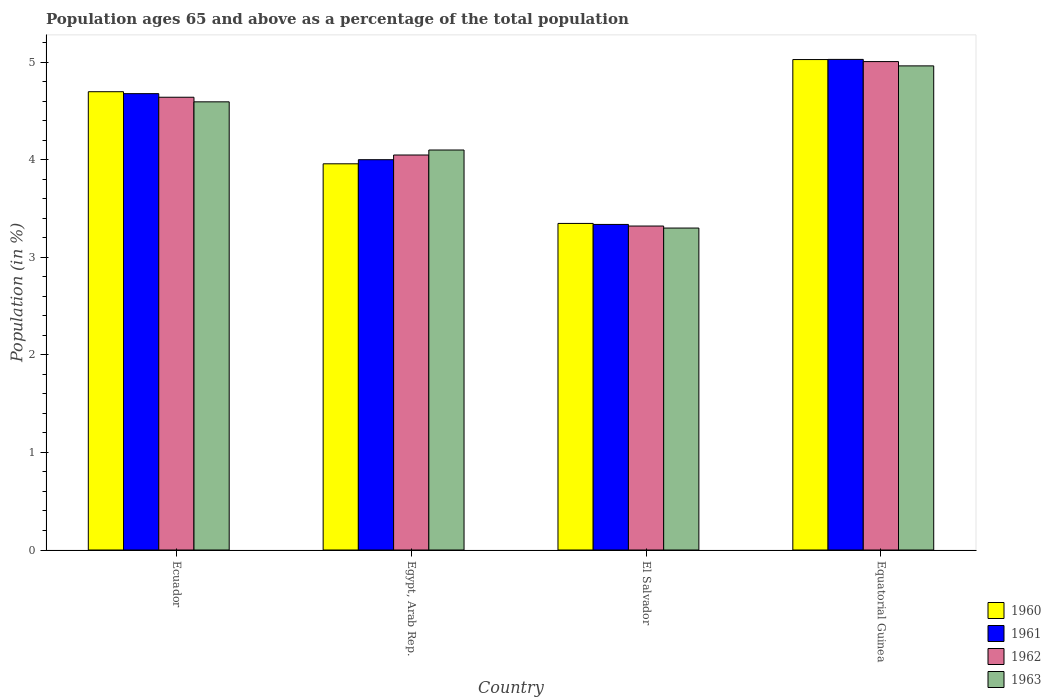How many different coloured bars are there?
Keep it short and to the point. 4. How many groups of bars are there?
Offer a very short reply. 4. Are the number of bars per tick equal to the number of legend labels?
Give a very brief answer. Yes. Are the number of bars on each tick of the X-axis equal?
Your answer should be compact. Yes. What is the label of the 1st group of bars from the left?
Give a very brief answer. Ecuador. In how many cases, is the number of bars for a given country not equal to the number of legend labels?
Give a very brief answer. 0. What is the percentage of the population ages 65 and above in 1963 in Egypt, Arab Rep.?
Give a very brief answer. 4.1. Across all countries, what is the maximum percentage of the population ages 65 and above in 1961?
Provide a short and direct response. 5.03. Across all countries, what is the minimum percentage of the population ages 65 and above in 1961?
Provide a succinct answer. 3.34. In which country was the percentage of the population ages 65 and above in 1962 maximum?
Offer a terse response. Equatorial Guinea. In which country was the percentage of the population ages 65 and above in 1961 minimum?
Your answer should be very brief. El Salvador. What is the total percentage of the population ages 65 and above in 1963 in the graph?
Provide a short and direct response. 16.95. What is the difference between the percentage of the population ages 65 and above in 1960 in Egypt, Arab Rep. and that in El Salvador?
Ensure brevity in your answer.  0.61. What is the difference between the percentage of the population ages 65 and above in 1960 in El Salvador and the percentage of the population ages 65 and above in 1963 in Equatorial Guinea?
Your response must be concise. -1.61. What is the average percentage of the population ages 65 and above in 1961 per country?
Provide a succinct answer. 4.26. What is the difference between the percentage of the population ages 65 and above of/in 1962 and percentage of the population ages 65 and above of/in 1960 in Equatorial Guinea?
Your answer should be compact. -0.02. In how many countries, is the percentage of the population ages 65 and above in 1960 greater than 2.8?
Your answer should be very brief. 4. What is the ratio of the percentage of the population ages 65 and above in 1960 in Egypt, Arab Rep. to that in Equatorial Guinea?
Make the answer very short. 0.79. Is the percentage of the population ages 65 and above in 1963 in Egypt, Arab Rep. less than that in Equatorial Guinea?
Keep it short and to the point. Yes. What is the difference between the highest and the second highest percentage of the population ages 65 and above in 1960?
Offer a terse response. -0.74. What is the difference between the highest and the lowest percentage of the population ages 65 and above in 1961?
Your answer should be very brief. 1.69. In how many countries, is the percentage of the population ages 65 and above in 1961 greater than the average percentage of the population ages 65 and above in 1961 taken over all countries?
Provide a succinct answer. 2. What does the 4th bar from the right in Ecuador represents?
Provide a succinct answer. 1960. Is it the case that in every country, the sum of the percentage of the population ages 65 and above in 1963 and percentage of the population ages 65 and above in 1960 is greater than the percentage of the population ages 65 and above in 1962?
Make the answer very short. Yes. How many bars are there?
Offer a very short reply. 16. What is the difference between two consecutive major ticks on the Y-axis?
Provide a short and direct response. 1. Are the values on the major ticks of Y-axis written in scientific E-notation?
Keep it short and to the point. No. Does the graph contain grids?
Provide a short and direct response. No. How many legend labels are there?
Your answer should be very brief. 4. How are the legend labels stacked?
Keep it short and to the point. Vertical. What is the title of the graph?
Offer a terse response. Population ages 65 and above as a percentage of the total population. What is the label or title of the X-axis?
Give a very brief answer. Country. What is the label or title of the Y-axis?
Your answer should be very brief. Population (in %). What is the Population (in %) of 1960 in Ecuador?
Provide a succinct answer. 4.7. What is the Population (in %) in 1961 in Ecuador?
Provide a succinct answer. 4.68. What is the Population (in %) of 1962 in Ecuador?
Provide a succinct answer. 4.64. What is the Population (in %) of 1963 in Ecuador?
Provide a succinct answer. 4.59. What is the Population (in %) in 1960 in Egypt, Arab Rep.?
Your answer should be compact. 3.96. What is the Population (in %) of 1961 in Egypt, Arab Rep.?
Offer a terse response. 4. What is the Population (in %) of 1962 in Egypt, Arab Rep.?
Ensure brevity in your answer.  4.05. What is the Population (in %) of 1963 in Egypt, Arab Rep.?
Keep it short and to the point. 4.1. What is the Population (in %) of 1960 in El Salvador?
Offer a very short reply. 3.35. What is the Population (in %) of 1961 in El Salvador?
Provide a short and direct response. 3.34. What is the Population (in %) of 1962 in El Salvador?
Offer a terse response. 3.32. What is the Population (in %) of 1963 in El Salvador?
Offer a very short reply. 3.3. What is the Population (in %) of 1960 in Equatorial Guinea?
Make the answer very short. 5.03. What is the Population (in %) of 1961 in Equatorial Guinea?
Provide a short and direct response. 5.03. What is the Population (in %) of 1962 in Equatorial Guinea?
Give a very brief answer. 5.01. What is the Population (in %) in 1963 in Equatorial Guinea?
Offer a very short reply. 4.96. Across all countries, what is the maximum Population (in %) in 1960?
Offer a very short reply. 5.03. Across all countries, what is the maximum Population (in %) of 1961?
Offer a very short reply. 5.03. Across all countries, what is the maximum Population (in %) of 1962?
Offer a very short reply. 5.01. Across all countries, what is the maximum Population (in %) of 1963?
Your answer should be compact. 4.96. Across all countries, what is the minimum Population (in %) of 1960?
Your answer should be very brief. 3.35. Across all countries, what is the minimum Population (in %) in 1961?
Offer a terse response. 3.34. Across all countries, what is the minimum Population (in %) in 1962?
Give a very brief answer. 3.32. Across all countries, what is the minimum Population (in %) of 1963?
Ensure brevity in your answer.  3.3. What is the total Population (in %) of 1960 in the graph?
Offer a very short reply. 17.03. What is the total Population (in %) in 1961 in the graph?
Your answer should be very brief. 17.04. What is the total Population (in %) of 1962 in the graph?
Provide a succinct answer. 17.01. What is the total Population (in %) in 1963 in the graph?
Provide a succinct answer. 16.95. What is the difference between the Population (in %) of 1960 in Ecuador and that in Egypt, Arab Rep.?
Provide a short and direct response. 0.74. What is the difference between the Population (in %) of 1961 in Ecuador and that in Egypt, Arab Rep.?
Offer a very short reply. 0.68. What is the difference between the Population (in %) of 1962 in Ecuador and that in Egypt, Arab Rep.?
Your answer should be very brief. 0.59. What is the difference between the Population (in %) of 1963 in Ecuador and that in Egypt, Arab Rep.?
Your answer should be compact. 0.49. What is the difference between the Population (in %) in 1960 in Ecuador and that in El Salvador?
Give a very brief answer. 1.35. What is the difference between the Population (in %) of 1961 in Ecuador and that in El Salvador?
Your answer should be very brief. 1.34. What is the difference between the Population (in %) of 1962 in Ecuador and that in El Salvador?
Give a very brief answer. 1.32. What is the difference between the Population (in %) in 1963 in Ecuador and that in El Salvador?
Offer a very short reply. 1.29. What is the difference between the Population (in %) in 1960 in Ecuador and that in Equatorial Guinea?
Ensure brevity in your answer.  -0.33. What is the difference between the Population (in %) in 1961 in Ecuador and that in Equatorial Guinea?
Give a very brief answer. -0.35. What is the difference between the Population (in %) in 1962 in Ecuador and that in Equatorial Guinea?
Your response must be concise. -0.37. What is the difference between the Population (in %) in 1963 in Ecuador and that in Equatorial Guinea?
Make the answer very short. -0.37. What is the difference between the Population (in %) in 1960 in Egypt, Arab Rep. and that in El Salvador?
Keep it short and to the point. 0.61. What is the difference between the Population (in %) of 1961 in Egypt, Arab Rep. and that in El Salvador?
Ensure brevity in your answer.  0.66. What is the difference between the Population (in %) in 1962 in Egypt, Arab Rep. and that in El Salvador?
Your answer should be very brief. 0.73. What is the difference between the Population (in %) of 1963 in Egypt, Arab Rep. and that in El Salvador?
Ensure brevity in your answer.  0.8. What is the difference between the Population (in %) in 1960 in Egypt, Arab Rep. and that in Equatorial Guinea?
Your answer should be very brief. -1.07. What is the difference between the Population (in %) of 1961 in Egypt, Arab Rep. and that in Equatorial Guinea?
Offer a very short reply. -1.03. What is the difference between the Population (in %) in 1962 in Egypt, Arab Rep. and that in Equatorial Guinea?
Offer a very short reply. -0.96. What is the difference between the Population (in %) of 1963 in Egypt, Arab Rep. and that in Equatorial Guinea?
Provide a short and direct response. -0.86. What is the difference between the Population (in %) in 1960 in El Salvador and that in Equatorial Guinea?
Ensure brevity in your answer.  -1.68. What is the difference between the Population (in %) of 1961 in El Salvador and that in Equatorial Guinea?
Provide a short and direct response. -1.69. What is the difference between the Population (in %) of 1962 in El Salvador and that in Equatorial Guinea?
Give a very brief answer. -1.69. What is the difference between the Population (in %) in 1963 in El Salvador and that in Equatorial Guinea?
Make the answer very short. -1.66. What is the difference between the Population (in %) of 1960 in Ecuador and the Population (in %) of 1961 in Egypt, Arab Rep.?
Provide a succinct answer. 0.7. What is the difference between the Population (in %) of 1960 in Ecuador and the Population (in %) of 1962 in Egypt, Arab Rep.?
Keep it short and to the point. 0.65. What is the difference between the Population (in %) of 1960 in Ecuador and the Population (in %) of 1963 in Egypt, Arab Rep.?
Keep it short and to the point. 0.6. What is the difference between the Population (in %) in 1961 in Ecuador and the Population (in %) in 1962 in Egypt, Arab Rep.?
Offer a very short reply. 0.63. What is the difference between the Population (in %) in 1961 in Ecuador and the Population (in %) in 1963 in Egypt, Arab Rep.?
Give a very brief answer. 0.58. What is the difference between the Population (in %) of 1962 in Ecuador and the Population (in %) of 1963 in Egypt, Arab Rep.?
Your answer should be very brief. 0.54. What is the difference between the Population (in %) in 1960 in Ecuador and the Population (in %) in 1961 in El Salvador?
Provide a succinct answer. 1.36. What is the difference between the Population (in %) of 1960 in Ecuador and the Population (in %) of 1962 in El Salvador?
Your answer should be compact. 1.38. What is the difference between the Population (in %) of 1960 in Ecuador and the Population (in %) of 1963 in El Salvador?
Provide a short and direct response. 1.4. What is the difference between the Population (in %) of 1961 in Ecuador and the Population (in %) of 1962 in El Salvador?
Your answer should be very brief. 1.36. What is the difference between the Population (in %) of 1961 in Ecuador and the Population (in %) of 1963 in El Salvador?
Provide a short and direct response. 1.38. What is the difference between the Population (in %) of 1962 in Ecuador and the Population (in %) of 1963 in El Salvador?
Keep it short and to the point. 1.34. What is the difference between the Population (in %) in 1960 in Ecuador and the Population (in %) in 1961 in Equatorial Guinea?
Offer a terse response. -0.33. What is the difference between the Population (in %) of 1960 in Ecuador and the Population (in %) of 1962 in Equatorial Guinea?
Offer a very short reply. -0.31. What is the difference between the Population (in %) of 1960 in Ecuador and the Population (in %) of 1963 in Equatorial Guinea?
Ensure brevity in your answer.  -0.26. What is the difference between the Population (in %) of 1961 in Ecuador and the Population (in %) of 1962 in Equatorial Guinea?
Offer a very short reply. -0.33. What is the difference between the Population (in %) in 1961 in Ecuador and the Population (in %) in 1963 in Equatorial Guinea?
Your response must be concise. -0.28. What is the difference between the Population (in %) in 1962 in Ecuador and the Population (in %) in 1963 in Equatorial Guinea?
Give a very brief answer. -0.32. What is the difference between the Population (in %) in 1960 in Egypt, Arab Rep. and the Population (in %) in 1961 in El Salvador?
Give a very brief answer. 0.62. What is the difference between the Population (in %) of 1960 in Egypt, Arab Rep. and the Population (in %) of 1962 in El Salvador?
Offer a terse response. 0.64. What is the difference between the Population (in %) in 1960 in Egypt, Arab Rep. and the Population (in %) in 1963 in El Salvador?
Keep it short and to the point. 0.66. What is the difference between the Population (in %) of 1961 in Egypt, Arab Rep. and the Population (in %) of 1962 in El Salvador?
Offer a terse response. 0.68. What is the difference between the Population (in %) in 1961 in Egypt, Arab Rep. and the Population (in %) in 1963 in El Salvador?
Your answer should be very brief. 0.7. What is the difference between the Population (in %) in 1962 in Egypt, Arab Rep. and the Population (in %) in 1963 in El Salvador?
Offer a terse response. 0.75. What is the difference between the Population (in %) of 1960 in Egypt, Arab Rep. and the Population (in %) of 1961 in Equatorial Guinea?
Your answer should be very brief. -1.07. What is the difference between the Population (in %) of 1960 in Egypt, Arab Rep. and the Population (in %) of 1962 in Equatorial Guinea?
Offer a very short reply. -1.05. What is the difference between the Population (in %) in 1960 in Egypt, Arab Rep. and the Population (in %) in 1963 in Equatorial Guinea?
Offer a terse response. -1. What is the difference between the Population (in %) in 1961 in Egypt, Arab Rep. and the Population (in %) in 1962 in Equatorial Guinea?
Provide a short and direct response. -1.01. What is the difference between the Population (in %) of 1961 in Egypt, Arab Rep. and the Population (in %) of 1963 in Equatorial Guinea?
Your answer should be compact. -0.96. What is the difference between the Population (in %) of 1962 in Egypt, Arab Rep. and the Population (in %) of 1963 in Equatorial Guinea?
Provide a short and direct response. -0.91. What is the difference between the Population (in %) of 1960 in El Salvador and the Population (in %) of 1961 in Equatorial Guinea?
Provide a succinct answer. -1.68. What is the difference between the Population (in %) in 1960 in El Salvador and the Population (in %) in 1962 in Equatorial Guinea?
Give a very brief answer. -1.66. What is the difference between the Population (in %) of 1960 in El Salvador and the Population (in %) of 1963 in Equatorial Guinea?
Your response must be concise. -1.61. What is the difference between the Population (in %) of 1961 in El Salvador and the Population (in %) of 1962 in Equatorial Guinea?
Your answer should be compact. -1.67. What is the difference between the Population (in %) of 1961 in El Salvador and the Population (in %) of 1963 in Equatorial Guinea?
Your answer should be very brief. -1.62. What is the difference between the Population (in %) of 1962 in El Salvador and the Population (in %) of 1963 in Equatorial Guinea?
Provide a succinct answer. -1.64. What is the average Population (in %) in 1960 per country?
Provide a succinct answer. 4.26. What is the average Population (in %) of 1961 per country?
Keep it short and to the point. 4.26. What is the average Population (in %) of 1962 per country?
Your response must be concise. 4.25. What is the average Population (in %) of 1963 per country?
Your answer should be very brief. 4.24. What is the difference between the Population (in %) of 1960 and Population (in %) of 1961 in Ecuador?
Provide a succinct answer. 0.02. What is the difference between the Population (in %) of 1960 and Population (in %) of 1962 in Ecuador?
Your answer should be compact. 0.06. What is the difference between the Population (in %) of 1960 and Population (in %) of 1963 in Ecuador?
Ensure brevity in your answer.  0.1. What is the difference between the Population (in %) in 1961 and Population (in %) in 1962 in Ecuador?
Make the answer very short. 0.04. What is the difference between the Population (in %) of 1961 and Population (in %) of 1963 in Ecuador?
Provide a succinct answer. 0.08. What is the difference between the Population (in %) in 1962 and Population (in %) in 1963 in Ecuador?
Your response must be concise. 0.05. What is the difference between the Population (in %) in 1960 and Population (in %) in 1961 in Egypt, Arab Rep.?
Keep it short and to the point. -0.04. What is the difference between the Population (in %) of 1960 and Population (in %) of 1962 in Egypt, Arab Rep.?
Give a very brief answer. -0.09. What is the difference between the Population (in %) in 1960 and Population (in %) in 1963 in Egypt, Arab Rep.?
Give a very brief answer. -0.14. What is the difference between the Population (in %) of 1961 and Population (in %) of 1962 in Egypt, Arab Rep.?
Offer a very short reply. -0.05. What is the difference between the Population (in %) of 1961 and Population (in %) of 1963 in Egypt, Arab Rep.?
Provide a succinct answer. -0.1. What is the difference between the Population (in %) of 1962 and Population (in %) of 1963 in Egypt, Arab Rep.?
Provide a succinct answer. -0.05. What is the difference between the Population (in %) in 1960 and Population (in %) in 1961 in El Salvador?
Ensure brevity in your answer.  0.01. What is the difference between the Population (in %) in 1960 and Population (in %) in 1962 in El Salvador?
Provide a short and direct response. 0.03. What is the difference between the Population (in %) of 1960 and Population (in %) of 1963 in El Salvador?
Ensure brevity in your answer.  0.05. What is the difference between the Population (in %) of 1961 and Population (in %) of 1962 in El Salvador?
Offer a very short reply. 0.02. What is the difference between the Population (in %) in 1961 and Population (in %) in 1963 in El Salvador?
Your response must be concise. 0.04. What is the difference between the Population (in %) of 1962 and Population (in %) of 1963 in El Salvador?
Your response must be concise. 0.02. What is the difference between the Population (in %) of 1960 and Population (in %) of 1961 in Equatorial Guinea?
Ensure brevity in your answer.  -0. What is the difference between the Population (in %) of 1960 and Population (in %) of 1962 in Equatorial Guinea?
Your response must be concise. 0.02. What is the difference between the Population (in %) of 1960 and Population (in %) of 1963 in Equatorial Guinea?
Provide a short and direct response. 0.06. What is the difference between the Population (in %) of 1961 and Population (in %) of 1962 in Equatorial Guinea?
Your answer should be compact. 0.02. What is the difference between the Population (in %) in 1961 and Population (in %) in 1963 in Equatorial Guinea?
Offer a terse response. 0.07. What is the difference between the Population (in %) in 1962 and Population (in %) in 1963 in Equatorial Guinea?
Your response must be concise. 0.04. What is the ratio of the Population (in %) in 1960 in Ecuador to that in Egypt, Arab Rep.?
Make the answer very short. 1.19. What is the ratio of the Population (in %) in 1961 in Ecuador to that in Egypt, Arab Rep.?
Your response must be concise. 1.17. What is the ratio of the Population (in %) of 1962 in Ecuador to that in Egypt, Arab Rep.?
Ensure brevity in your answer.  1.15. What is the ratio of the Population (in %) of 1963 in Ecuador to that in Egypt, Arab Rep.?
Your answer should be compact. 1.12. What is the ratio of the Population (in %) of 1960 in Ecuador to that in El Salvador?
Make the answer very short. 1.4. What is the ratio of the Population (in %) of 1961 in Ecuador to that in El Salvador?
Offer a terse response. 1.4. What is the ratio of the Population (in %) of 1962 in Ecuador to that in El Salvador?
Give a very brief answer. 1.4. What is the ratio of the Population (in %) of 1963 in Ecuador to that in El Salvador?
Your answer should be very brief. 1.39. What is the ratio of the Population (in %) in 1960 in Ecuador to that in Equatorial Guinea?
Ensure brevity in your answer.  0.93. What is the ratio of the Population (in %) in 1961 in Ecuador to that in Equatorial Guinea?
Your answer should be compact. 0.93. What is the ratio of the Population (in %) of 1962 in Ecuador to that in Equatorial Guinea?
Keep it short and to the point. 0.93. What is the ratio of the Population (in %) in 1963 in Ecuador to that in Equatorial Guinea?
Provide a succinct answer. 0.93. What is the ratio of the Population (in %) in 1960 in Egypt, Arab Rep. to that in El Salvador?
Offer a terse response. 1.18. What is the ratio of the Population (in %) in 1961 in Egypt, Arab Rep. to that in El Salvador?
Keep it short and to the point. 1.2. What is the ratio of the Population (in %) of 1962 in Egypt, Arab Rep. to that in El Salvador?
Keep it short and to the point. 1.22. What is the ratio of the Population (in %) of 1963 in Egypt, Arab Rep. to that in El Salvador?
Provide a succinct answer. 1.24. What is the ratio of the Population (in %) in 1960 in Egypt, Arab Rep. to that in Equatorial Guinea?
Your response must be concise. 0.79. What is the ratio of the Population (in %) of 1961 in Egypt, Arab Rep. to that in Equatorial Guinea?
Provide a short and direct response. 0.8. What is the ratio of the Population (in %) of 1962 in Egypt, Arab Rep. to that in Equatorial Guinea?
Your answer should be very brief. 0.81. What is the ratio of the Population (in %) in 1963 in Egypt, Arab Rep. to that in Equatorial Guinea?
Provide a succinct answer. 0.83. What is the ratio of the Population (in %) of 1960 in El Salvador to that in Equatorial Guinea?
Your answer should be compact. 0.67. What is the ratio of the Population (in %) of 1961 in El Salvador to that in Equatorial Guinea?
Your answer should be compact. 0.66. What is the ratio of the Population (in %) in 1962 in El Salvador to that in Equatorial Guinea?
Your response must be concise. 0.66. What is the ratio of the Population (in %) of 1963 in El Salvador to that in Equatorial Guinea?
Provide a short and direct response. 0.67. What is the difference between the highest and the second highest Population (in %) in 1960?
Your answer should be very brief. 0.33. What is the difference between the highest and the second highest Population (in %) in 1961?
Your answer should be compact. 0.35. What is the difference between the highest and the second highest Population (in %) in 1962?
Offer a terse response. 0.37. What is the difference between the highest and the second highest Population (in %) in 1963?
Your answer should be compact. 0.37. What is the difference between the highest and the lowest Population (in %) in 1960?
Offer a very short reply. 1.68. What is the difference between the highest and the lowest Population (in %) in 1961?
Your answer should be very brief. 1.69. What is the difference between the highest and the lowest Population (in %) of 1962?
Provide a succinct answer. 1.69. What is the difference between the highest and the lowest Population (in %) in 1963?
Your answer should be very brief. 1.66. 